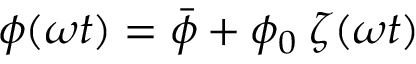<formula> <loc_0><loc_0><loc_500><loc_500>\phi ( \omega t ) = \bar { \phi } + \phi _ { 0 } \, \zeta ( \omega t )</formula> 